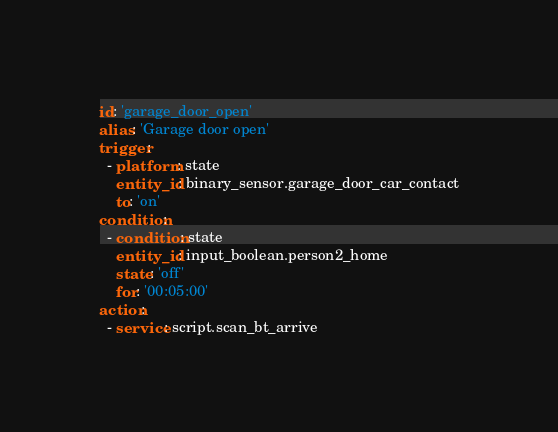Convert code to text. <code><loc_0><loc_0><loc_500><loc_500><_YAML_>id: 'garage_door_open'
alias: 'Garage door open'
trigger:
  - platform: state
    entity_id: binary_sensor.garage_door_car_contact
    to: 'on'
condition:
  - condition: state
    entity_id: input_boolean.person2_home
    state: 'off'
    for: '00:05:00'
action:
  - service: script.scan_bt_arrive
</code> 